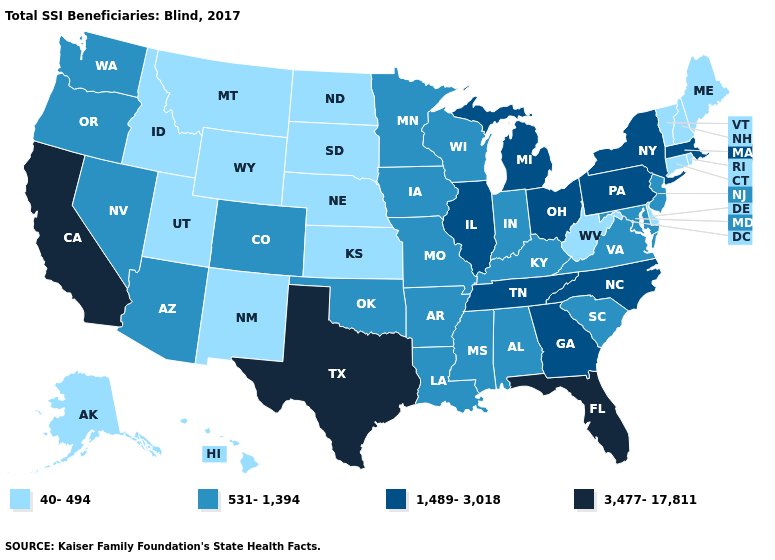Does Wisconsin have a lower value than New York?
Give a very brief answer. Yes. What is the lowest value in the South?
Short answer required. 40-494. Does Hawaii have the lowest value in the USA?
Write a very short answer. Yes. Is the legend a continuous bar?
Answer briefly. No. What is the lowest value in the USA?
Answer briefly. 40-494. What is the value of Indiana?
Short answer required. 531-1,394. Among the states that border California , which have the lowest value?
Give a very brief answer. Arizona, Nevada, Oregon. What is the highest value in the West ?
Concise answer only. 3,477-17,811. Among the states that border Tennessee , which have the highest value?
Concise answer only. Georgia, North Carolina. What is the lowest value in states that border Arizona?
Write a very short answer. 40-494. Does Idaho have a lower value than Maine?
Keep it brief. No. What is the value of North Dakota?
Write a very short answer. 40-494. What is the lowest value in the West?
Write a very short answer. 40-494. Is the legend a continuous bar?
Answer briefly. No. Among the states that border Connecticut , which have the highest value?
Answer briefly. Massachusetts, New York. 